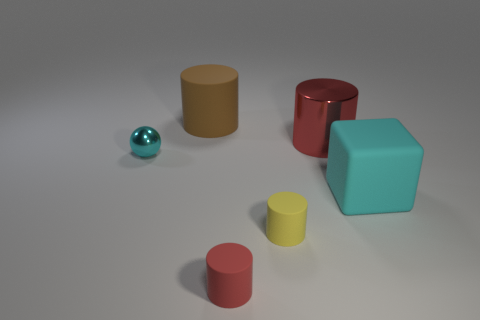There is a big cube that is the same color as the tiny shiny ball; what is its material?
Keep it short and to the point. Rubber. There is a rubber object behind the big block; is it the same size as the cyan thing that is to the right of the tiny metal sphere?
Keep it short and to the point. Yes. What color is the rubber object that is behind the cyan metal thing?
Keep it short and to the point. Brown. Are there fewer large cylinders that are to the right of the red shiny cylinder than blue cubes?
Your answer should be very brief. No. Is the material of the brown cylinder the same as the cube?
Offer a very short reply. Yes. What is the size of the yellow rubber thing that is the same shape as the red rubber thing?
Offer a terse response. Small. What number of objects are tiny things right of the big brown rubber cylinder or large things that are to the left of the large cyan matte object?
Your answer should be compact. 4. Are there fewer large purple metal cubes than small cyan metallic balls?
Provide a succinct answer. Yes. There is a red shiny thing; does it have the same size as the brown cylinder that is on the right side of the ball?
Make the answer very short. Yes. How many metal objects are either small yellow cylinders or spheres?
Make the answer very short. 1. 